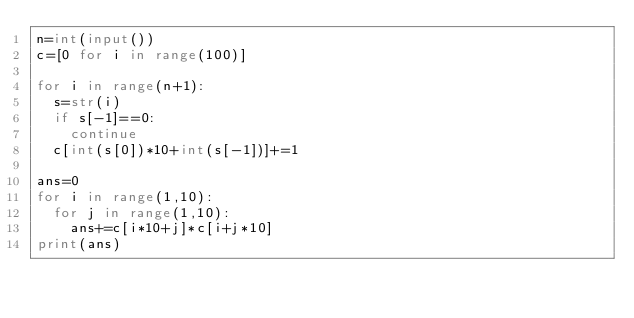Convert code to text. <code><loc_0><loc_0><loc_500><loc_500><_Python_>n=int(input())
c=[0 for i in range(100)]

for i in range(n+1):
  s=str(i)
  if s[-1]==0:
    continue
  c[int(s[0])*10+int(s[-1])]+=1

ans=0
for i in range(1,10):
  for j in range(1,10):
    ans+=c[i*10+j]*c[i+j*10]
print(ans)</code> 